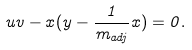Convert formula to latex. <formula><loc_0><loc_0><loc_500><loc_500>u v - x ( y - \frac { 1 } { m _ { a d j } } x ) = 0 .</formula> 